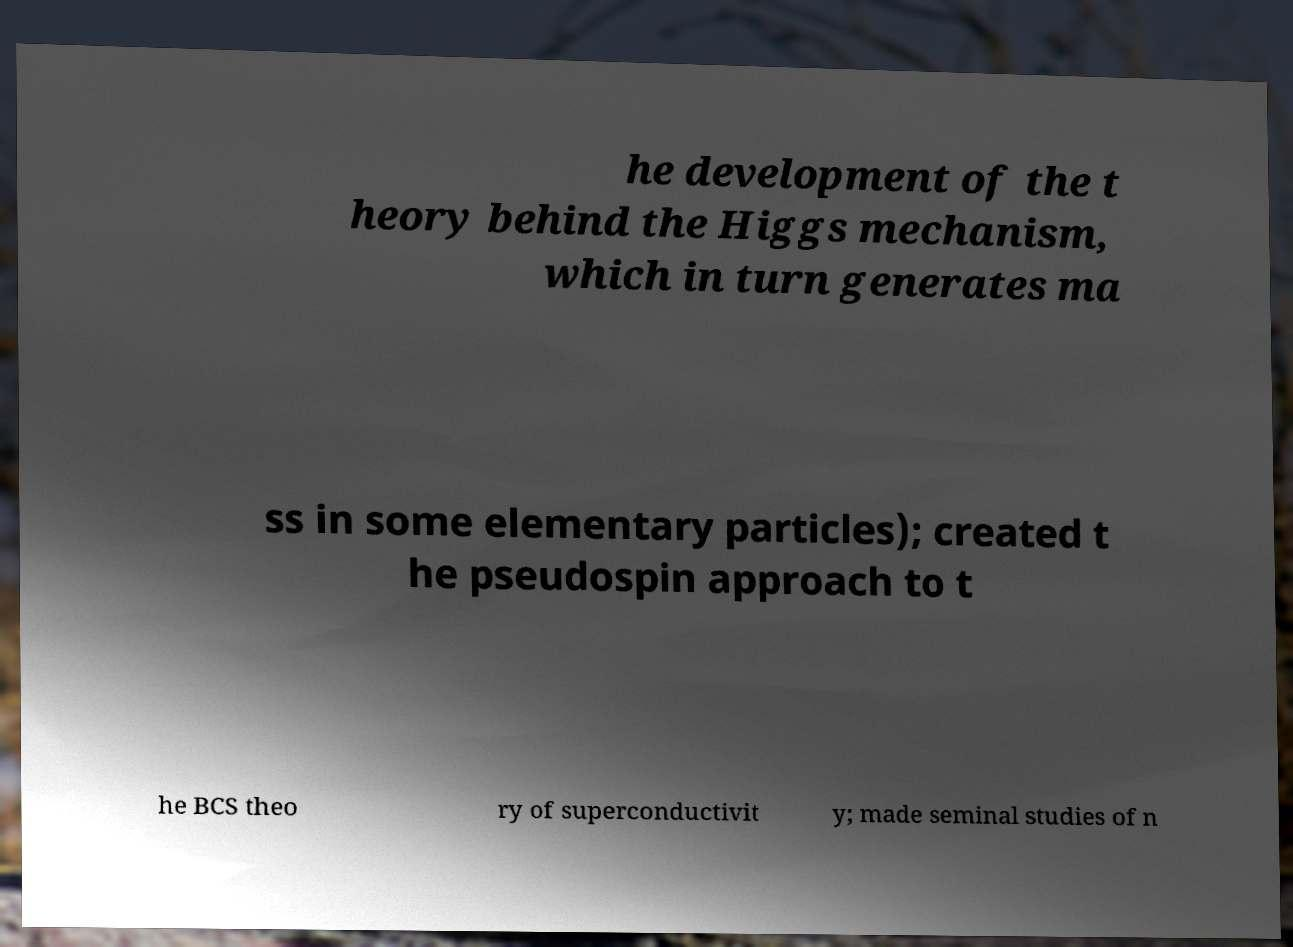Please identify and transcribe the text found in this image. he development of the t heory behind the Higgs mechanism, which in turn generates ma ss in some elementary particles); created t he pseudospin approach to t he BCS theo ry of superconductivit y; made seminal studies of n 